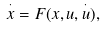Convert formula to latex. <formula><loc_0><loc_0><loc_500><loc_500>\overset { \cdot } { x } = F ( x , u , \overset { \cdot } { u } ) ,</formula> 